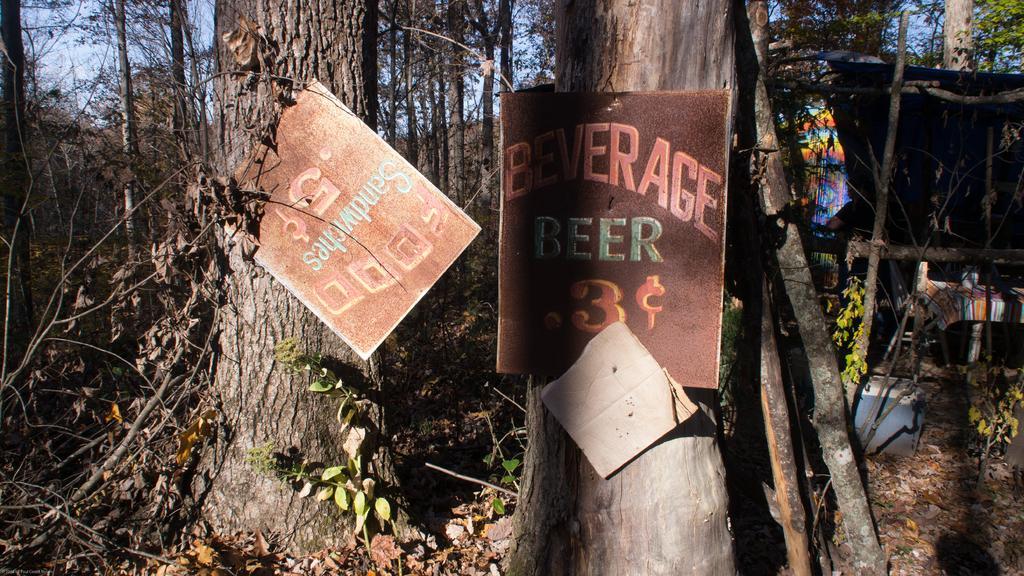Can you describe this image briefly? In this image there are a group of trees, and on the trees there are some boats and on the right side there are some objects. At the bottom there is grass and dry leaves. 